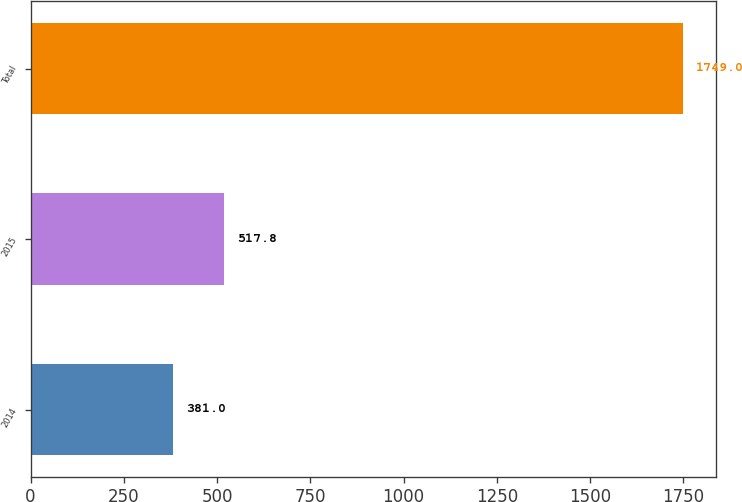Convert chart to OTSL. <chart><loc_0><loc_0><loc_500><loc_500><bar_chart><fcel>2014<fcel>2015<fcel>Total<nl><fcel>381<fcel>517.8<fcel>1749<nl></chart> 